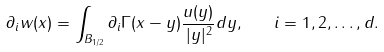Convert formula to latex. <formula><loc_0><loc_0><loc_500><loc_500>\partial _ { i } w ( x ) = \int _ { B _ { 1 / 2 } } \partial _ { i } \Gamma ( x - y ) \frac { u ( y ) } { | y | ^ { 2 } } d y , \quad i = 1 , 2 , \dots , d .</formula> 